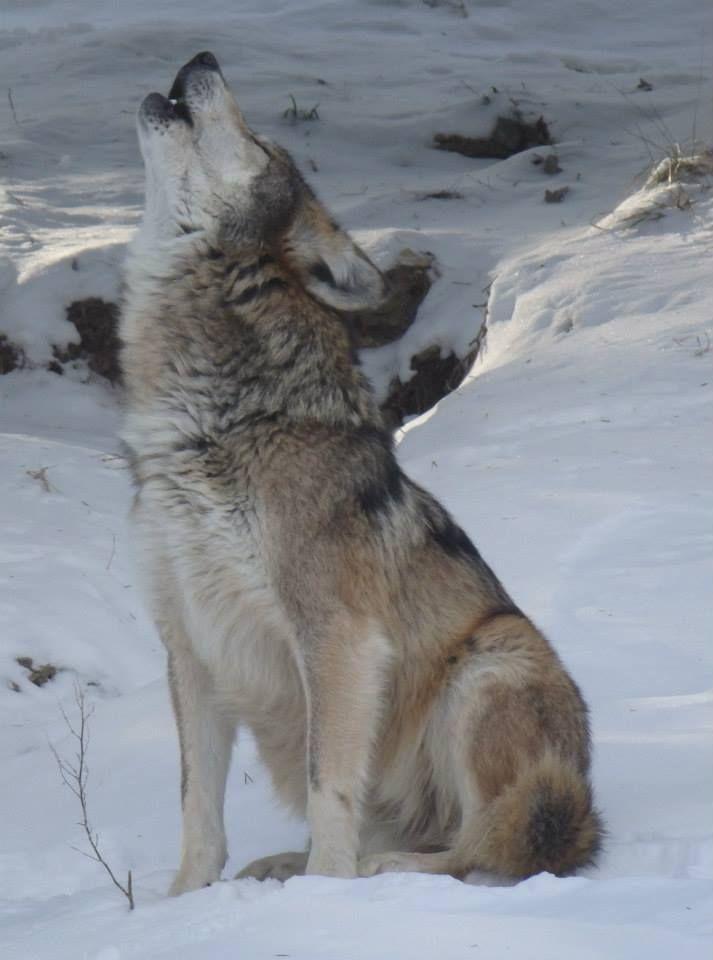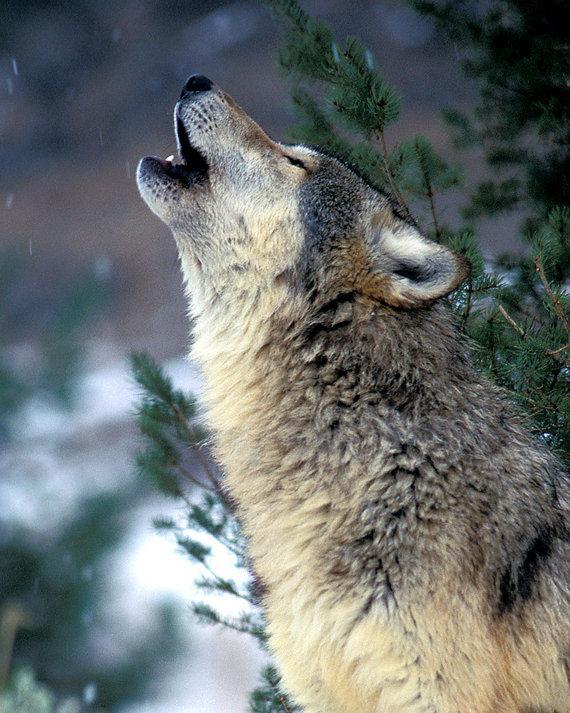The first image is the image on the left, the second image is the image on the right. For the images displayed, is the sentence "There are only two dogs and both are howling at the sky." factually correct? Answer yes or no. Yes. The first image is the image on the left, the second image is the image on the right. Examine the images to the left and right. Is the description "There are exactly two wolves howling in the snow." accurate? Answer yes or no. Yes. 